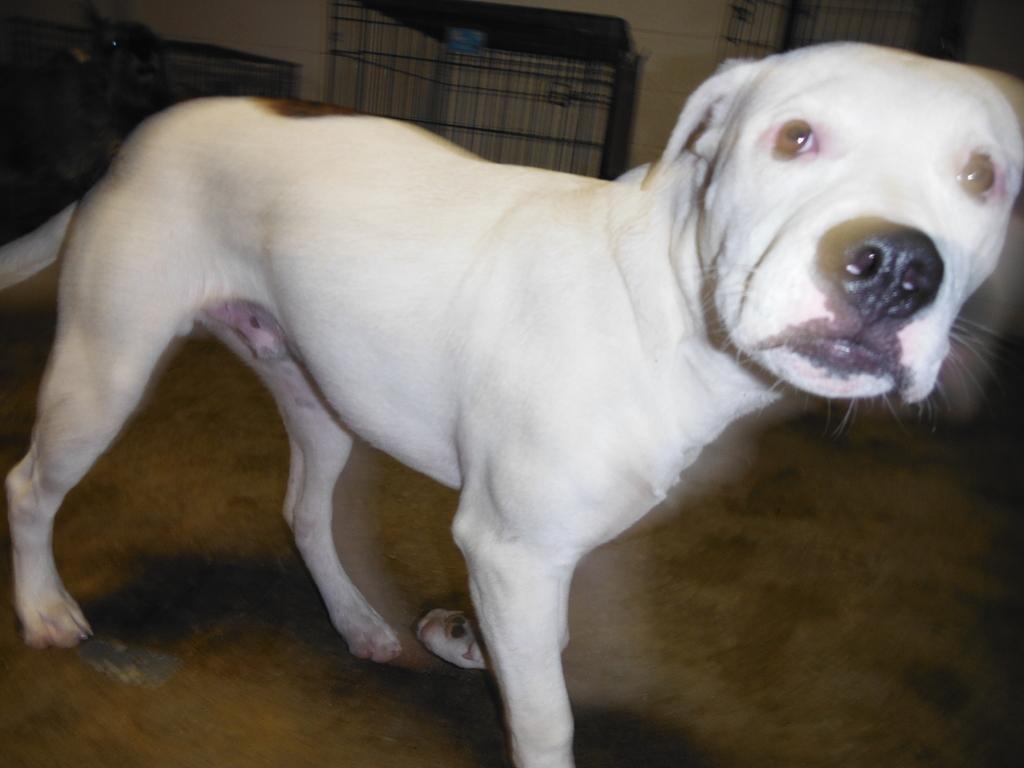How would you summarize this image in a sentence or two? In this image, we can see a dog which is colored white. There is a cage at the top of the image. 